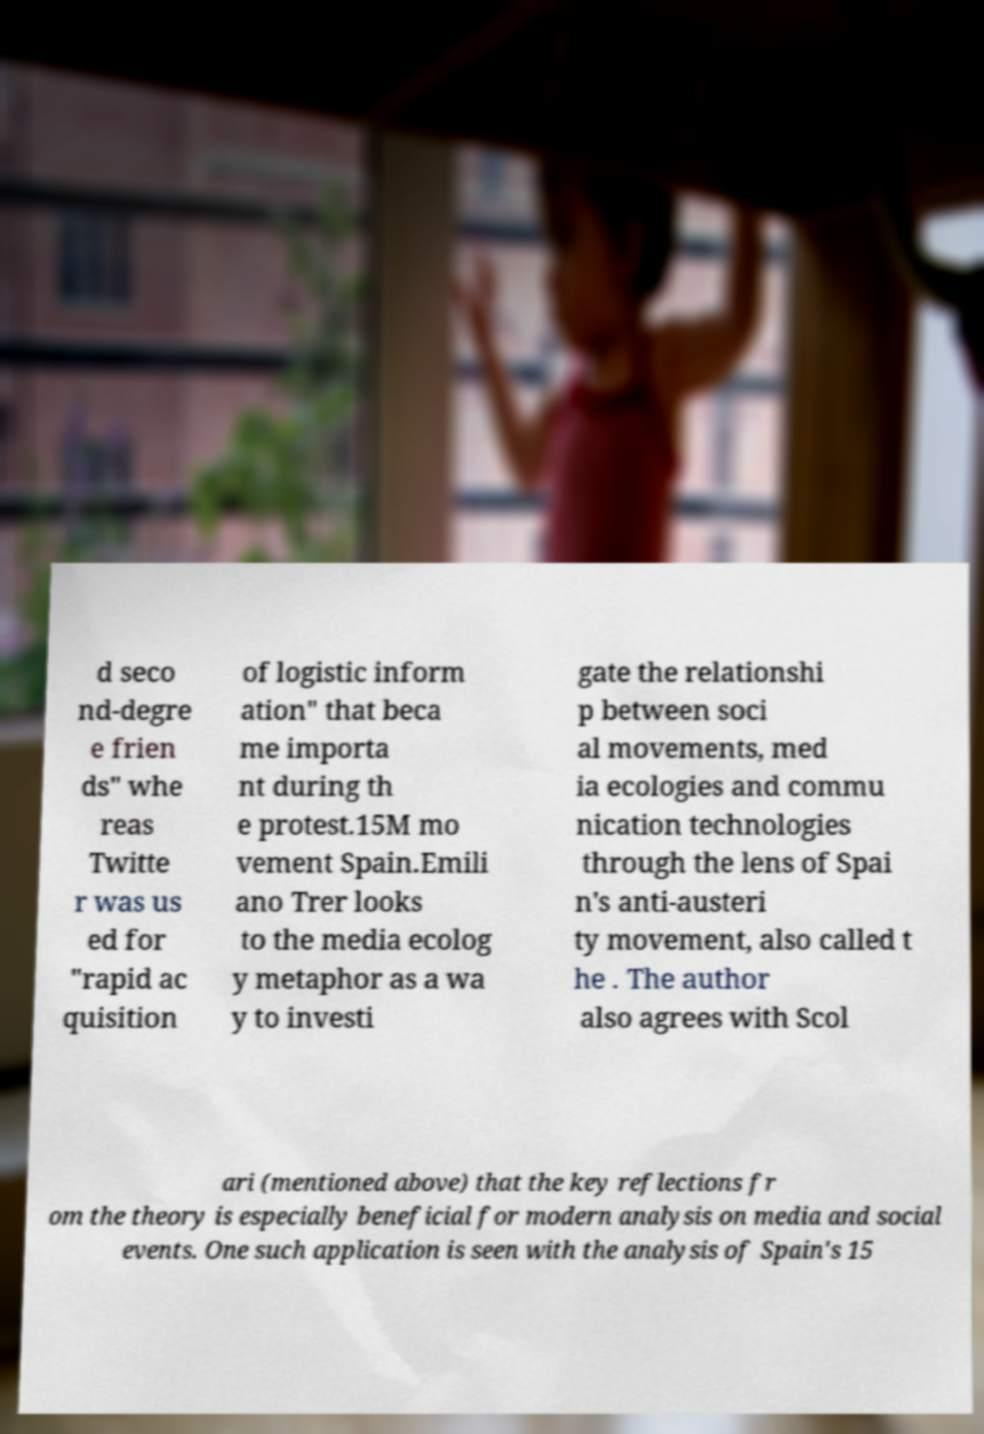I need the written content from this picture converted into text. Can you do that? d seco nd-degre e frien ds" whe reas Twitte r was us ed for "rapid ac quisition of logistic inform ation" that beca me importa nt during th e protest.15M mo vement Spain.Emili ano Trer looks to the media ecolog y metaphor as a wa y to investi gate the relationshi p between soci al movements, med ia ecologies and commu nication technologies through the lens of Spai n's anti-austeri ty movement, also called t he . The author also agrees with Scol ari (mentioned above) that the key reflections fr om the theory is especially beneficial for modern analysis on media and social events. One such application is seen with the analysis of Spain's 15 